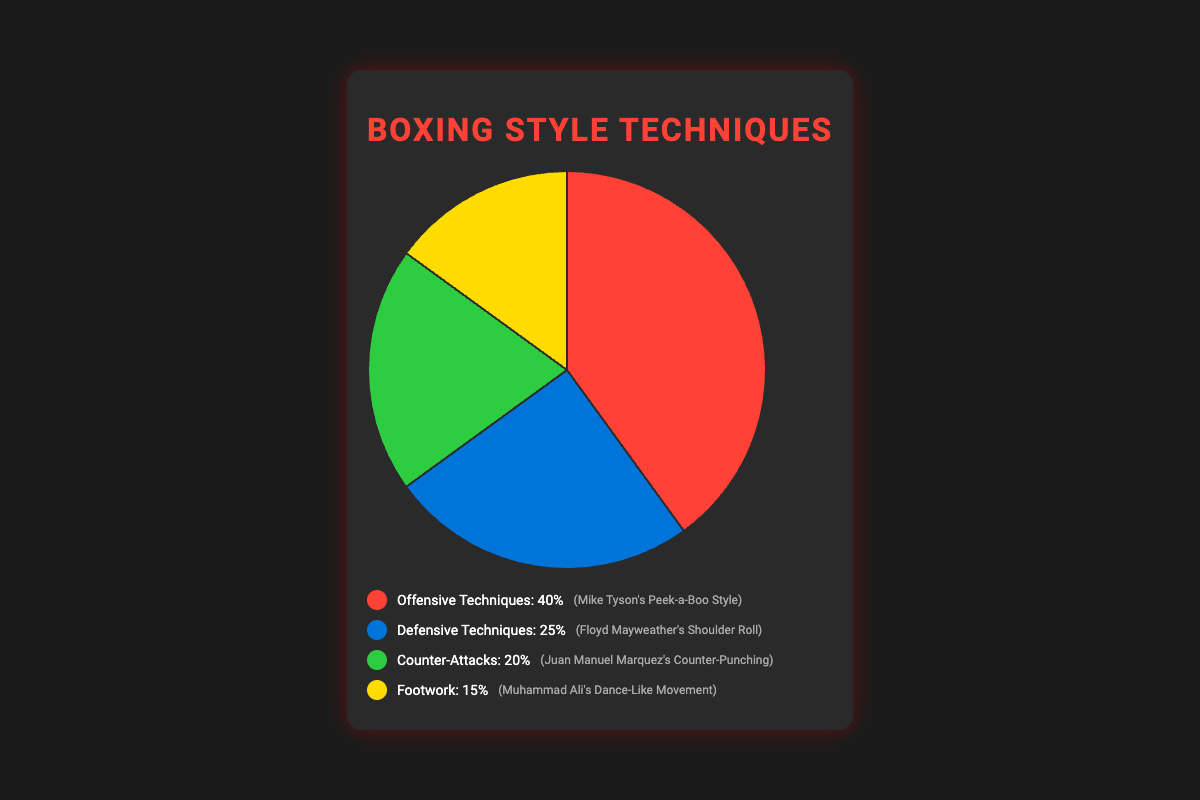Which technique is utilized the most in boxing fights? By looking at the pie chart, the slice representing Offensive Techniques is the largest. This indicates that Offensive Techniques are utilized the most.
Answer: Offensive Techniques What percentage of the techniques are Defensive Techniques? The pie chart shows that Defensive Techniques make up 25% of the total techniques used.
Answer: 25% How much more are Offensive Techniques used compared to Footwork? The pie chart shows Offensive Techniques at 40% and Footwork at 15%. The difference is 40% - 15% = 25%.
Answer: 25% Which techniques combined make up more than half of the total techniques utilized? Offensive Techniques (40%) and Defensive Techniques (25%) together contribute 40% + 25% = 65%, which is more than half.
Answer: Offensive Techniques and Defensive Techniques Among the techniques, which one is used the least? Footwork is represented by the smallest slice in the pie chart, indicating it has the lowest percentage, which is 15%.
Answer: Footwork By how much do Counter-Attacks and Footwork combined exceed Defensive Techniques? Counter-Attacks and Footwork combined make up 20% + 15% = 35%. Defensive Techniques make up 25%. The excess is 35% - 25% = 10%.
Answer: 10% What is the real-world example associated with the most utilized technique? According to the legend corresponding to the pie chart, the most utilized technique is Offensive Techniques, with a real-world example of "Mike Tyson's Peek-a-Boo Style".
Answer: Mike Tyson's Peek-a-Boo Style Which technique's percentage is closest to the combined total of Counter-Attacks and Footwork? Counter-Attacks make up 20% and Footwork makes up 15%, together totaling 20% + 15% = 35%. Offensive Techniques at 40% is closest to this sum.
Answer: Offensive Techniques 